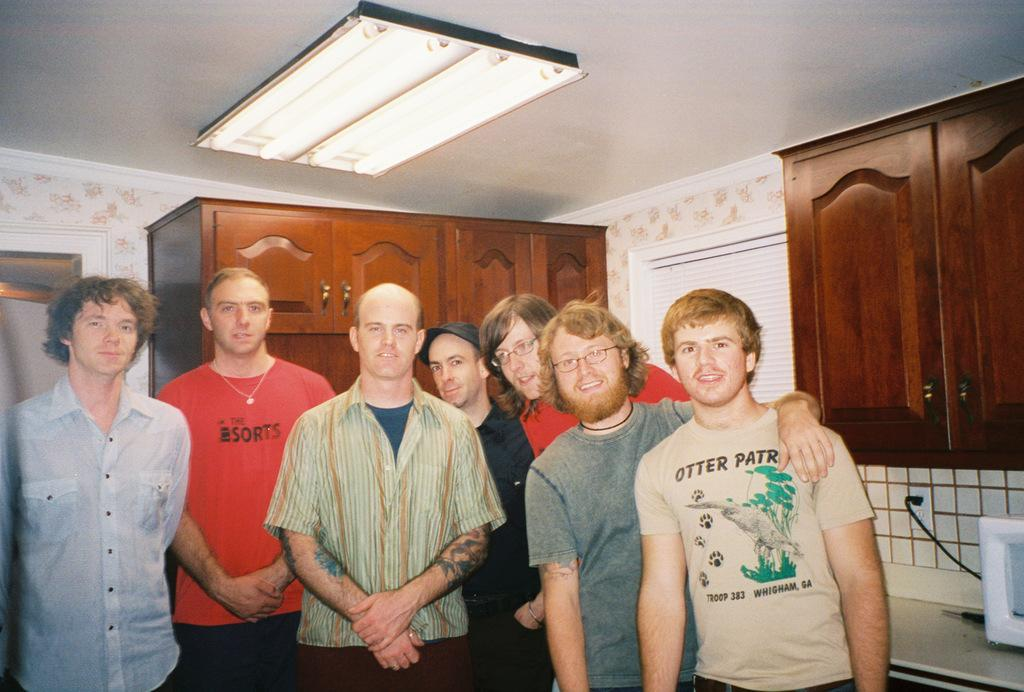What is happening in the image? There are people standing in the image. How can you describe the attire of the people? The people are wearing different color dresses. What can be seen in the background of the image? There are brown color cupboards, a machine, a wall, and a switch board visible in the background. What is present at the top of the image? Lights are visible at the top of the image. How many cracks can be seen on the wall in the image? There is no mention of cracks on the wall in the image, so we cannot determine the number of cracks. 